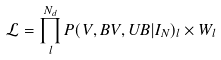<formula> <loc_0><loc_0><loc_500><loc_500>\mathcal { L } = \prod _ { l } ^ { N _ { d } } P ( V , B V , U B | I _ { N } ) _ { l } \times W _ { l }</formula> 